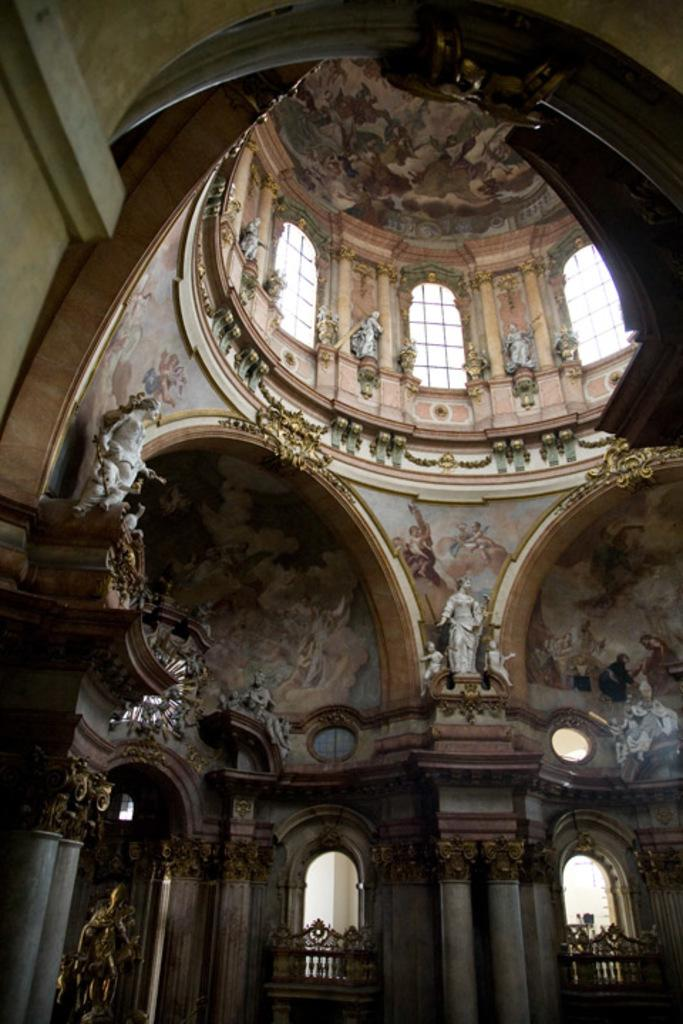What type of structure is shown in the image? The image is an inner view of a building. What architectural features can be seen in the image? There are pillars in the image. Are there any decorative elements in the image? Yes, there are sculptures in the image. What can be seen through the openings in the building? There are windows in the image. What is visible at the top of the image? There is a roof visible at the top of the image. What type of waves can be seen crashing against the shore in the image? There are no waves or shore visible in the image; it is an inner view of a building. What type of collar is worn by the sculpture in the image? There is no sculpture wearing a collar in the image; the sculptures do not have clothing or accessories. 